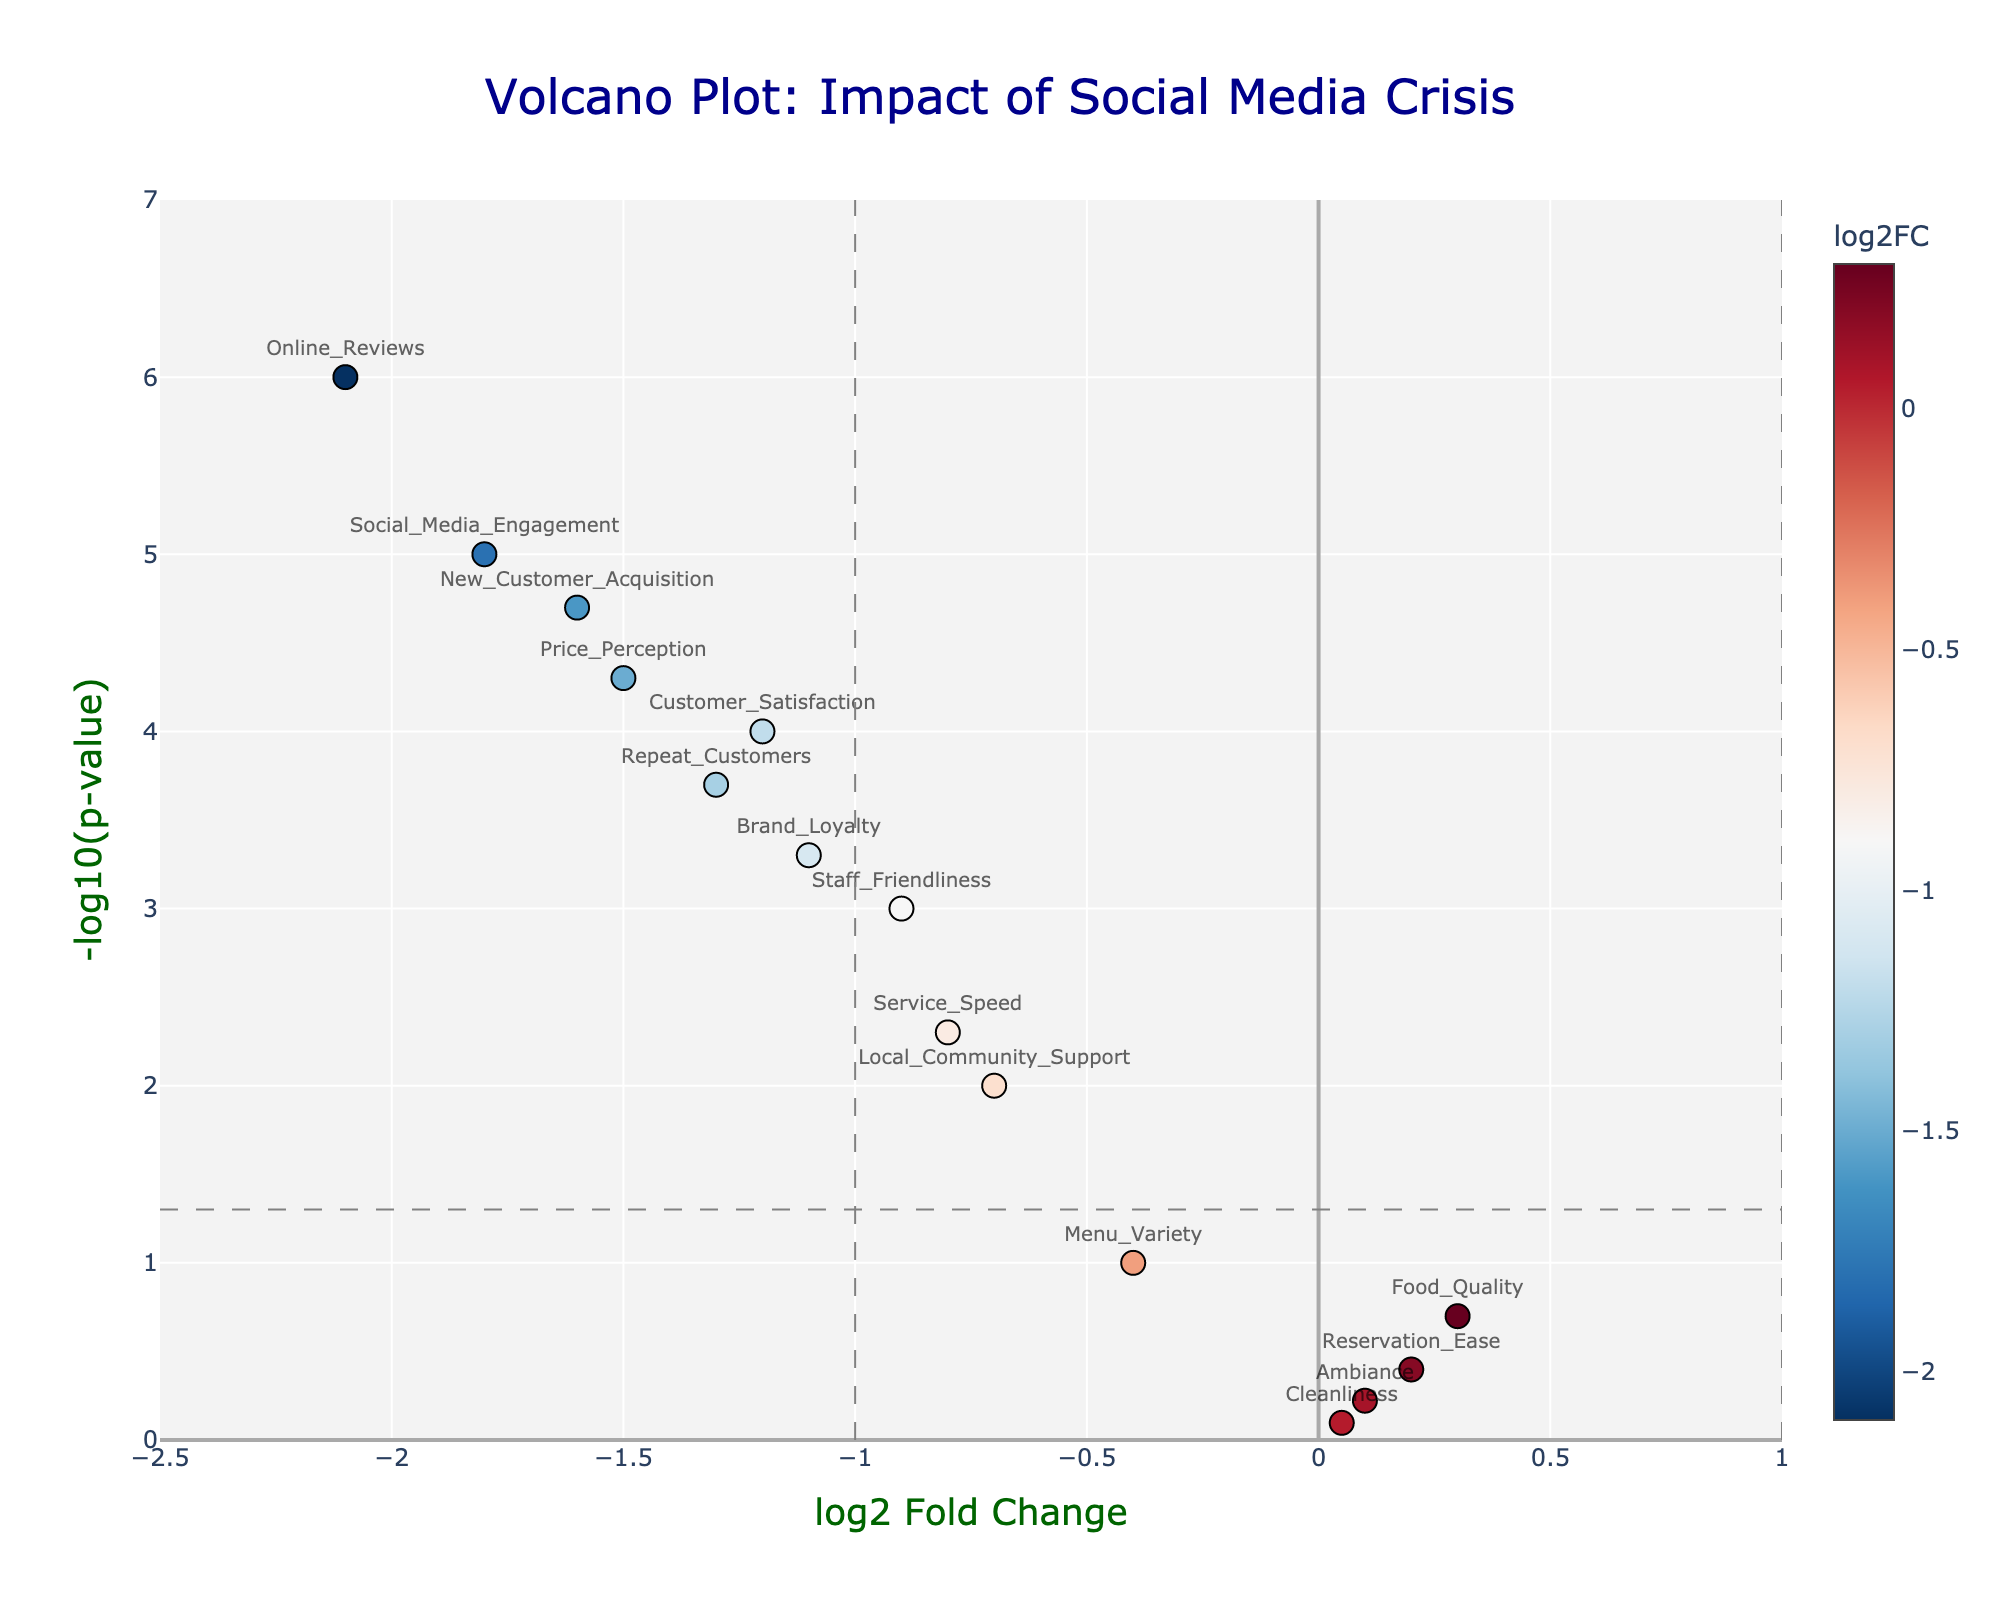What is the title of the volcano plot? The title is found at the center-top of the figure in prominent text. It summarizes the main insight the plot is conveying.
Answer: Volcano Plot: Impact of Social Media Crisis What is the x-axis title in the plot? The x-axis title is displayed horizontally along the bottom of the figure. It indicates the variable that is being plotted along this axis.
Answer: log2 Fold Change Which sentiment has the most significant negative change in the plot? Look for the point that is farthest to the left and highest up, indicating a strong negative log2 fold change and the lowest p-value.
Answer: Social_Media_Engagement How many sentiments have a log2 fold change less than -1? Identify the points to the left of the vertical line at x = -1 and count them.
Answer: 6 Which sentiment has a log2 fold change closest to zero? Look for the point that is closest to the vertical center line at x = 0.
Answer: Cleanliness What is the p-value threshold line represented by in the plot? The threshold line for the p-value is a visual guide shown as a horizontal dashed line, indicating a common significance level.
Answer: -log10(p-value) = 1.3 Which sentiments are statistically significant and negatively impacted by the social media crisis? Statistically significant points are above the horizontal line at -log10(p-value) = 1.3. For negative impact, look for points to the left of the vertical line at x = 0.
Answer: Social_Media_Engagement, Online_Reviews, New_Customer_Acquisition, Price_Perception, Repeat_Customers, Brand_Loyalty, Staff_Friendliness, Service_Speed, Customer_Satisfaction, Local_Community_Support Do any sentiments show a significant positive change after the social media crisis? Check if there are any points on the right side of the vertical line at x = 0 that are above the horizontal line at -log10(p-value) = 1.3.
Answer: No Which sentiment shows the least impact from the social media crisis? Look for the point (sentiment) that is closest to the origin (x = 0, y = 0) indicating minimal log2 fold change and highest p-value.
Answer: Cleanliness What is the color of points with the lowest log2 fold change in the plot? The points with the lowest log2 fold change are usually colored according to the color scale used, in this case, likely a deeper color based on the RdBu_r colorscale.
Answer: Red 